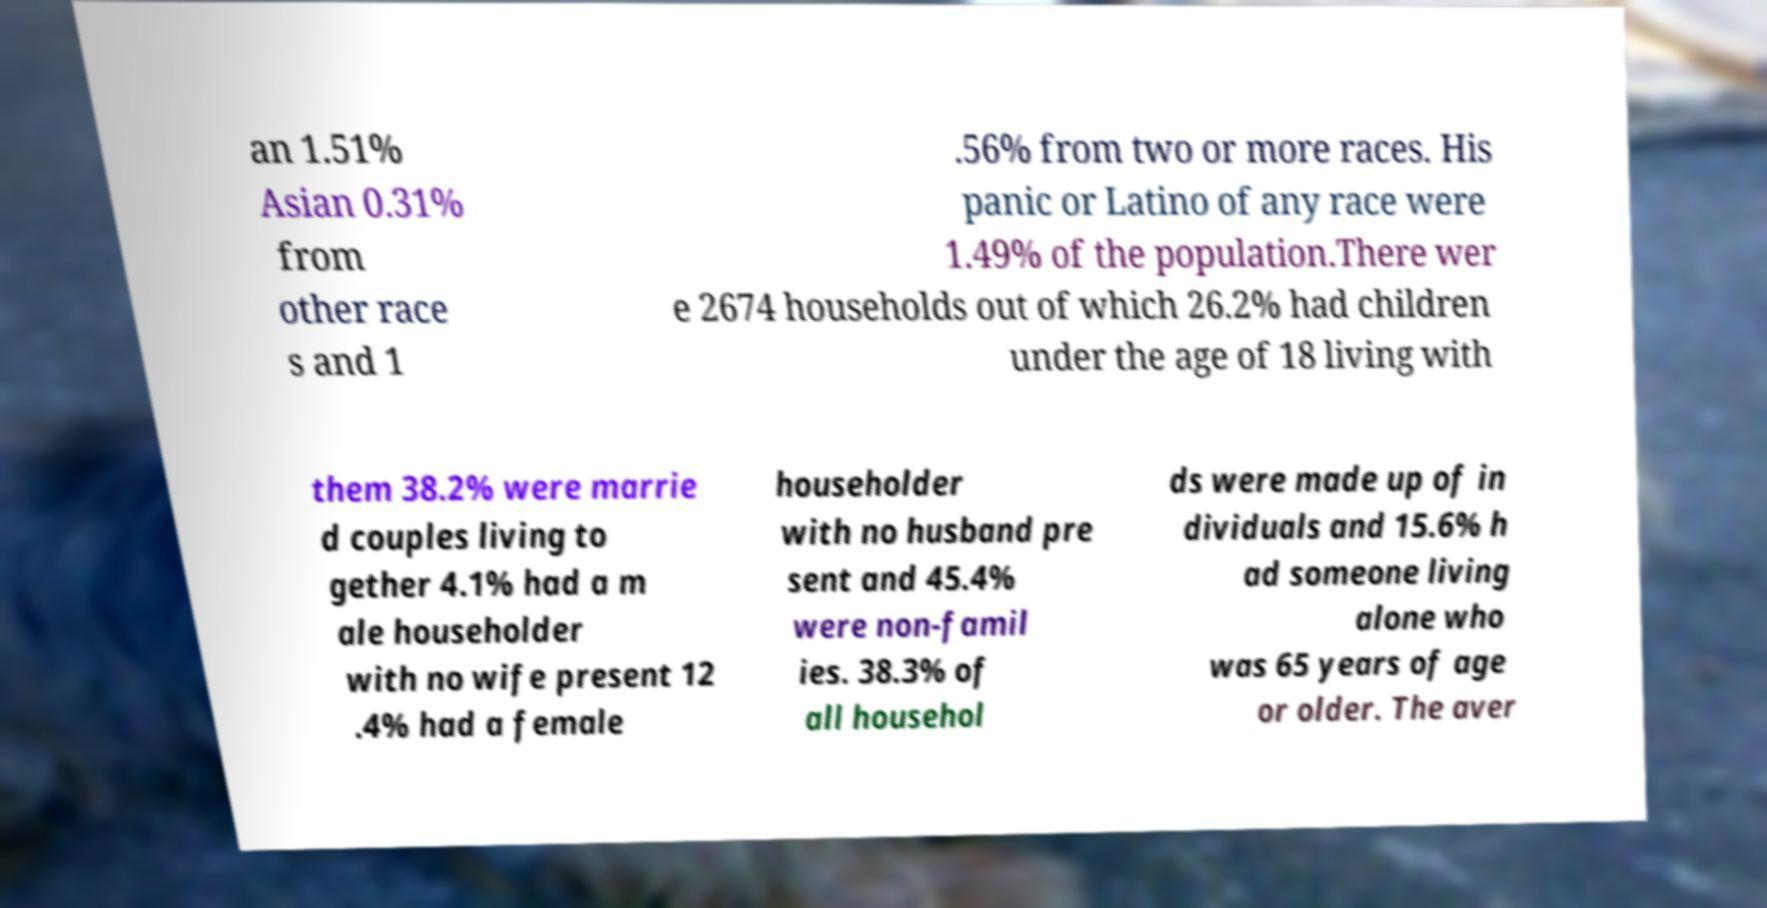Could you assist in decoding the text presented in this image and type it out clearly? an 1.51% Asian 0.31% from other race s and 1 .56% from two or more races. His panic or Latino of any race were 1.49% of the population.There wer e 2674 households out of which 26.2% had children under the age of 18 living with them 38.2% were marrie d couples living to gether 4.1% had a m ale householder with no wife present 12 .4% had a female householder with no husband pre sent and 45.4% were non-famil ies. 38.3% of all househol ds were made up of in dividuals and 15.6% h ad someone living alone who was 65 years of age or older. The aver 